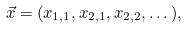Convert formula to latex. <formula><loc_0><loc_0><loc_500><loc_500>\vec { x } = ( x _ { 1 , 1 } , x _ { 2 , 1 } , x _ { 2 , 2 } , \dots ) ,</formula> 